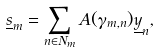Convert formula to latex. <formula><loc_0><loc_0><loc_500><loc_500>& \underline { s } _ { m } = \sum _ { n \in N _ { m } } A ( \gamma _ { m , n } ) \underline { y } _ { n } ,</formula> 